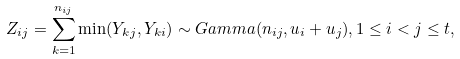Convert formula to latex. <formula><loc_0><loc_0><loc_500><loc_500>Z _ { i j } = \sum _ { k = 1 } ^ { n _ { i j } } \min ( Y _ { k j } , Y _ { k i } ) \sim G a m m a ( n _ { i j } , u _ { i } + u _ { j } ) , 1 \leq i < j \leq t ,</formula> 